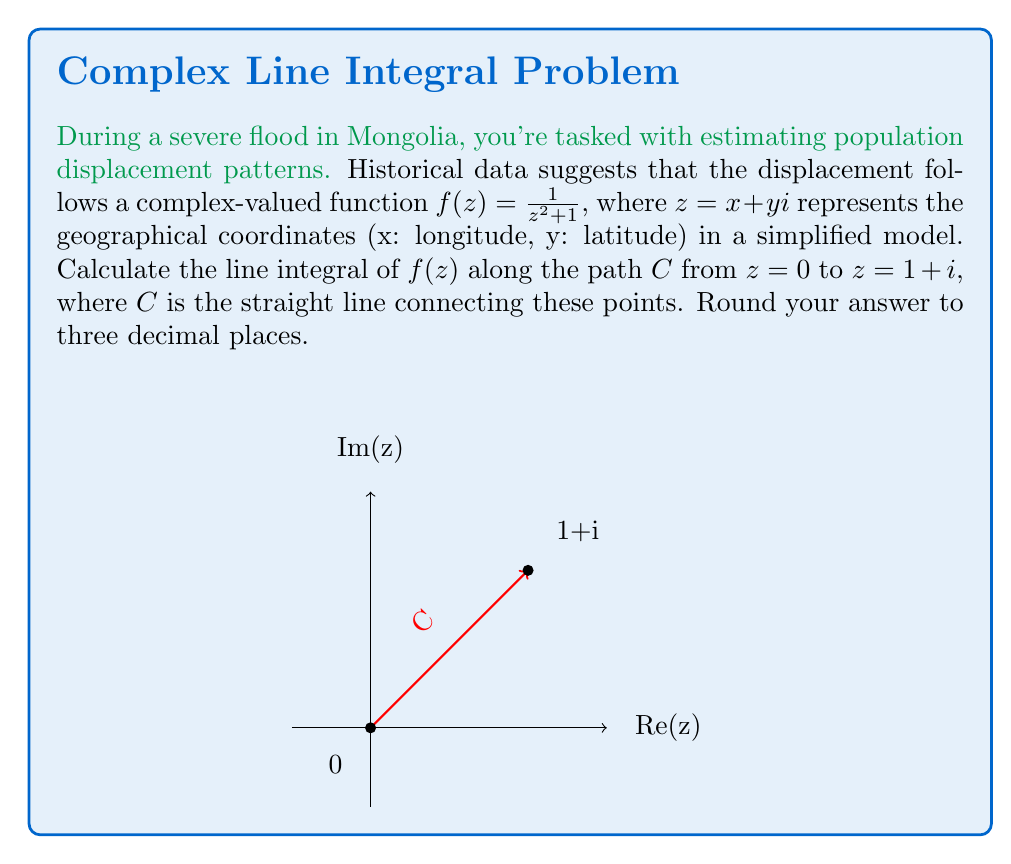Solve this math problem. To solve this problem, we'll use the following steps:

1) The line integral of a complex function $f(z)$ along a path $C$ is given by:

   $$\int_C f(z) dz = \int_a^b f(z(t)) z'(t) dt$$

   where $z(t)$ parametrizes the path $C$.

2) For a straight line from $z_1 = 0$ to $z_2 = 1+i$, we can use the parametrization:

   $z(t) = (1-t)z_1 + tz_2 = t(1+i)$, where $0 \leq t \leq 1$

3) Therefore, $z'(t) = 1+i$

4) Substituting into the integral:

   $$\int_C f(z) dz = \int_0^1 \frac{1}{(t(1+i))^2 + 1} (1+i) dt$$

5) Simplify the denominator:

   $(t(1+i))^2 + 1 = t^2(1+2i-1) + 1 = 2t^2i + 1$

6) Now our integral becomes:

   $$\int_0^1 \frac{1+i}{2t^2i + 1} dt$$

7) To integrate this, we can use the substitution $u = 2t^2i + 1$:

   $du = 4ti dt$
   $dt = \frac{du}{4ti}$

8) When $t=0$, $u=1$; when $t=1$, $u=2i+1$

9) Substituting:

   $$\int_1^{2i+1} \frac{1+i}{u} \cdot \frac{1}{4ti} du = \frac{1+i}{4i} \int_1^{2i+1} \frac{1}{tu} du$$

10) The integral of $1/u$ is $\ln(u)$, so:

    $$\frac{1+i}{4i} [\ln(u)]_1^{2i+1} = \frac{1+i}{4i} [\ln(2i+1) - \ln(1)]$$

11) Simplify:

    $$\frac{1+i}{4i} \ln(2i+1) = \frac{1+i}{4i} [\ln(\sqrt{5}) + i\arctan(2)]$$

12) Multiply out:

    $$\frac{1}{4} [\ln(\sqrt{5}) + i\arctan(2)] - \frac{i}{4} [\ln(\sqrt{5}) + i\arctan(2)]$$

13) Simplify and separate real and imaginary parts:

    $$(\frac{1}{4}\ln(\sqrt{5}) + \frac{1}{4}\arctan(2)) + i(\frac{1}{4}\arctan(2) - \frac{1}{4}\ln(\sqrt{5}))$$

14) Calculate numerically and round to three decimal places:

    $0.347 + 0.041i$
Answer: $0.347 + 0.041i$ 